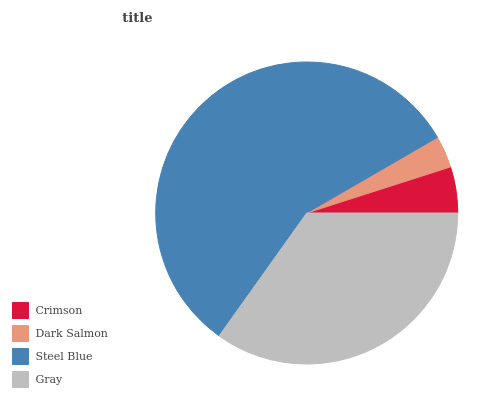Is Dark Salmon the minimum?
Answer yes or no. Yes. Is Steel Blue the maximum?
Answer yes or no. Yes. Is Steel Blue the minimum?
Answer yes or no. No. Is Dark Salmon the maximum?
Answer yes or no. No. Is Steel Blue greater than Dark Salmon?
Answer yes or no. Yes. Is Dark Salmon less than Steel Blue?
Answer yes or no. Yes. Is Dark Salmon greater than Steel Blue?
Answer yes or no. No. Is Steel Blue less than Dark Salmon?
Answer yes or no. No. Is Gray the high median?
Answer yes or no. Yes. Is Crimson the low median?
Answer yes or no. Yes. Is Crimson the high median?
Answer yes or no. No. Is Steel Blue the low median?
Answer yes or no. No. 